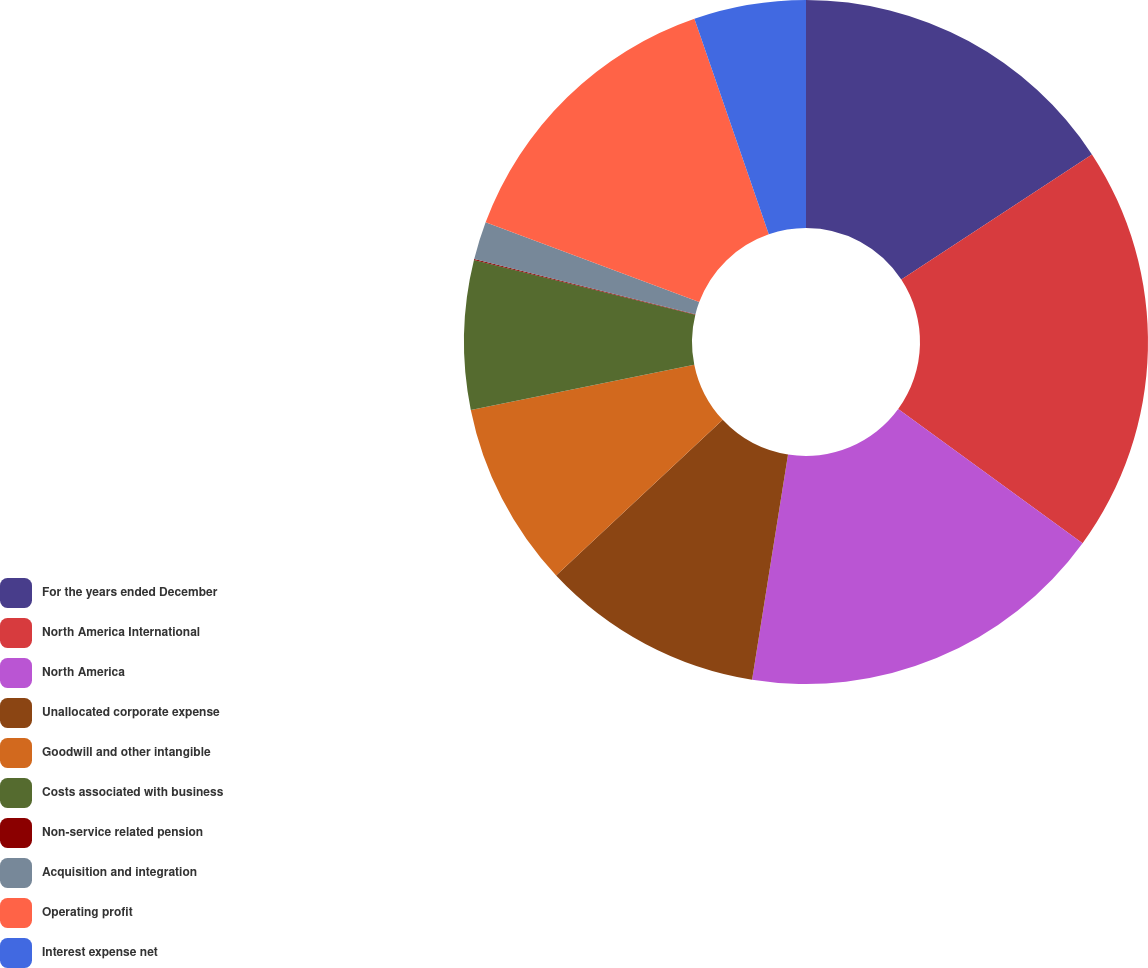Convert chart to OTSL. <chart><loc_0><loc_0><loc_500><loc_500><pie_chart><fcel>For the years ended December<fcel>North America International<fcel>North America<fcel>Unallocated corporate expense<fcel>Goodwill and other intangible<fcel>Costs associated with business<fcel>Non-service related pension<fcel>Acquisition and integration<fcel>Operating profit<fcel>Interest expense net<nl><fcel>15.76%<fcel>19.25%<fcel>17.51%<fcel>10.52%<fcel>8.78%<fcel>7.03%<fcel>0.05%<fcel>1.79%<fcel>14.02%<fcel>5.29%<nl></chart> 